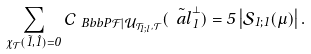<formula> <loc_0><loc_0><loc_500><loc_500>\sum _ { \chi _ { \mathcal { T } } ( \tilde { 1 } , \hat { 1 } ) = 0 } { \mathcal { C } } _ { \ B b b { P } { \mathcal { F } } | { \mathcal { U } } _ { { \mathcal { T } } _ { 1 ; l } , { \mathcal { T } } } } ( \tilde { \ a l } _ { 1 } ^ { \perp } ) = 5 \left | { \mathcal { S } } _ { 1 ; 1 } ( \mu ) \right | .</formula> 